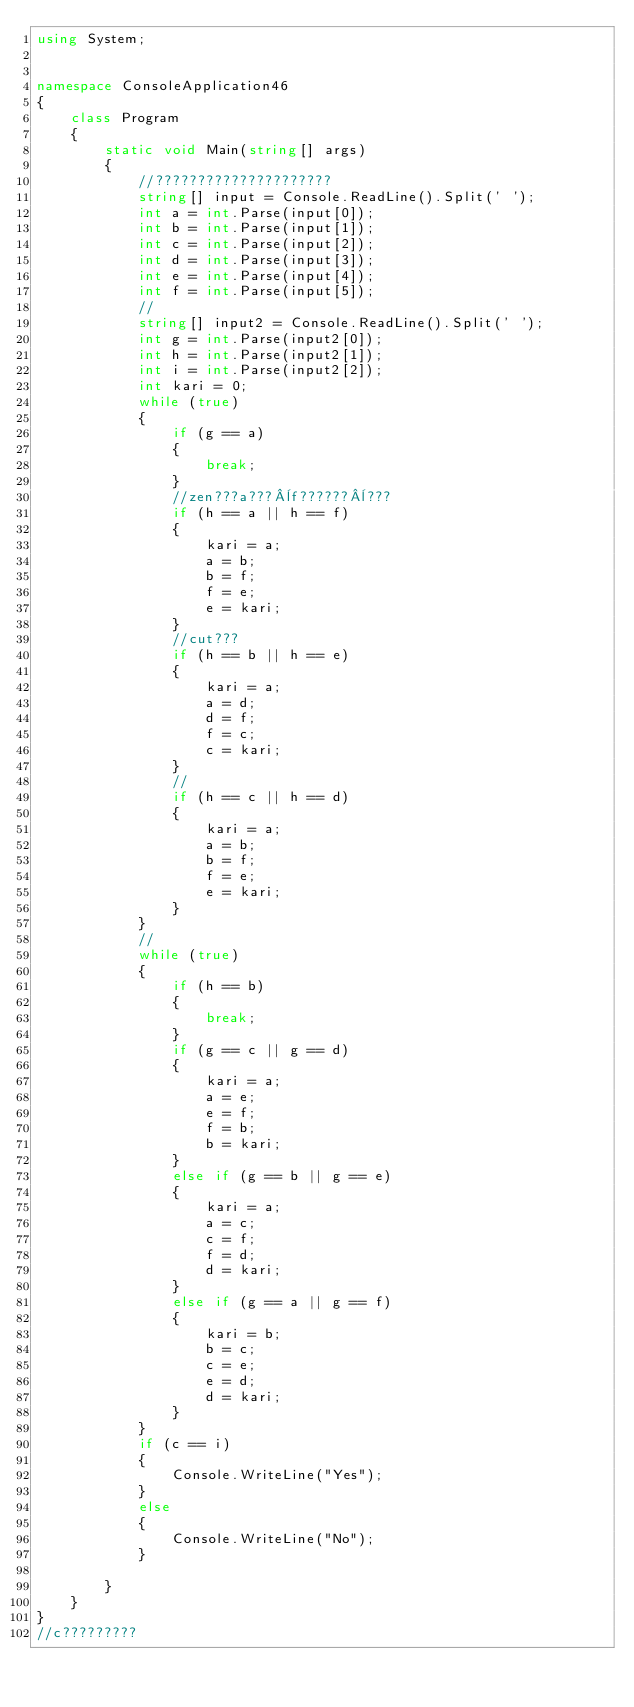<code> <loc_0><loc_0><loc_500><loc_500><_C#_>using System;
 
 
namespace ConsoleApplication46
{
    class Program
    {
        static void Main(string[] args)
        {
            //?????????????????????
            string[] input = Console.ReadLine().Split(' ');
            int a = int.Parse(input[0]);
            int b = int.Parse(input[1]);
            int c = int.Parse(input[2]);
            int d = int.Parse(input[3]);
            int e = int.Parse(input[4]);
            int f = int.Parse(input[5]);
            //
            string[] input2 = Console.ReadLine().Split(' ');
            int g = int.Parse(input2[0]);
            int h = int.Parse(input2[1]);
            int i = int.Parse(input2[2]);
            int kari = 0; 
            while (true)
            {
                if (g == a)
                {
                    break;
                }
                //zen???a???¨f??????¨???
                if (h == a || h == f)
                {
                    kari = a;
                    a = b;
                    b = f;
                    f = e;
                    e = kari;
                }
                //cut???
                if (h == b || h == e)
                {
                    kari = a;
                    a = d;
                    d = f;
                    f = c;
                    c = kari;
                }
                //
                if (h == c || h == d)
                {
                    kari = a;
                    a = b;
                    b = f;
                    f = e;
                    e = kari;
                }
            }
            //
            while (true)
            {
                if (h == b)
                {
                    break;
                }
                if (g == c || g == d)
                {
                    kari = a;
                    a = e;
                    e = f;
                    f = b;
                    b = kari;
                }
                else if (g == b || g == e)
                {
                    kari = a;
                    a = c;
                    c = f;
                    f = d;
                    d = kari;
                }
                else if (g == a || g == f)
                {
                    kari = b;
                    b = c;
                    c = e;
                    e = d;
                    d = kari;
                }
            }
            if (c == i)
            {
                Console.WriteLine("Yes");
            }
            else
            {
                Console.WriteLine("No");
            }
 
        }
    }
}
//c?????????</code> 